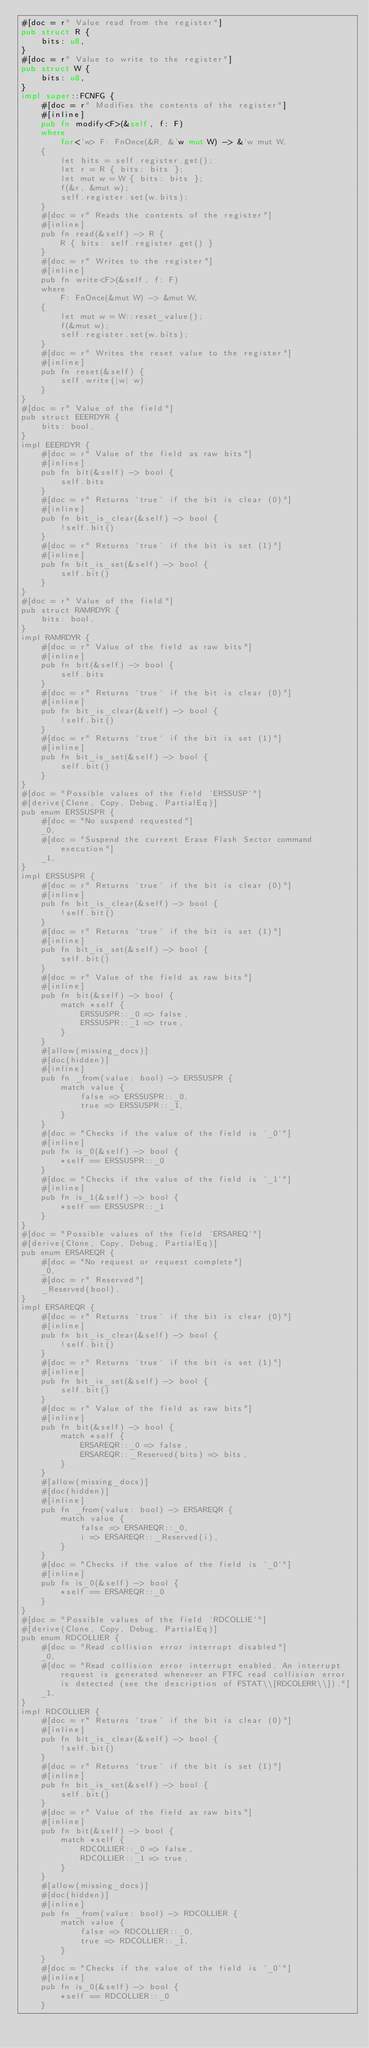<code> <loc_0><loc_0><loc_500><loc_500><_Rust_>#[doc = r" Value read from the register"]
pub struct R {
    bits: u8,
}
#[doc = r" Value to write to the register"]
pub struct W {
    bits: u8,
}
impl super::FCNFG {
    #[doc = r" Modifies the contents of the register"]
    #[inline]
    pub fn modify<F>(&self, f: F)
    where
        for<'w> F: FnOnce(&R, &'w mut W) -> &'w mut W,
    {
        let bits = self.register.get();
        let r = R { bits: bits };
        let mut w = W { bits: bits };
        f(&r, &mut w);
        self.register.set(w.bits);
    }
    #[doc = r" Reads the contents of the register"]
    #[inline]
    pub fn read(&self) -> R {
        R { bits: self.register.get() }
    }
    #[doc = r" Writes to the register"]
    #[inline]
    pub fn write<F>(&self, f: F)
    where
        F: FnOnce(&mut W) -> &mut W,
    {
        let mut w = W::reset_value();
        f(&mut w);
        self.register.set(w.bits);
    }
    #[doc = r" Writes the reset value to the register"]
    #[inline]
    pub fn reset(&self) {
        self.write(|w| w)
    }
}
#[doc = r" Value of the field"]
pub struct EEERDYR {
    bits: bool,
}
impl EEERDYR {
    #[doc = r" Value of the field as raw bits"]
    #[inline]
    pub fn bit(&self) -> bool {
        self.bits
    }
    #[doc = r" Returns `true` if the bit is clear (0)"]
    #[inline]
    pub fn bit_is_clear(&self) -> bool {
        !self.bit()
    }
    #[doc = r" Returns `true` if the bit is set (1)"]
    #[inline]
    pub fn bit_is_set(&self) -> bool {
        self.bit()
    }
}
#[doc = r" Value of the field"]
pub struct RAMRDYR {
    bits: bool,
}
impl RAMRDYR {
    #[doc = r" Value of the field as raw bits"]
    #[inline]
    pub fn bit(&self) -> bool {
        self.bits
    }
    #[doc = r" Returns `true` if the bit is clear (0)"]
    #[inline]
    pub fn bit_is_clear(&self) -> bool {
        !self.bit()
    }
    #[doc = r" Returns `true` if the bit is set (1)"]
    #[inline]
    pub fn bit_is_set(&self) -> bool {
        self.bit()
    }
}
#[doc = "Possible values of the field `ERSSUSP`"]
#[derive(Clone, Copy, Debug, PartialEq)]
pub enum ERSSUSPR {
    #[doc = "No suspend requested"]
    _0,
    #[doc = "Suspend the current Erase Flash Sector command execution"]
    _1,
}
impl ERSSUSPR {
    #[doc = r" Returns `true` if the bit is clear (0)"]
    #[inline]
    pub fn bit_is_clear(&self) -> bool {
        !self.bit()
    }
    #[doc = r" Returns `true` if the bit is set (1)"]
    #[inline]
    pub fn bit_is_set(&self) -> bool {
        self.bit()
    }
    #[doc = r" Value of the field as raw bits"]
    #[inline]
    pub fn bit(&self) -> bool {
        match *self {
            ERSSUSPR::_0 => false,
            ERSSUSPR::_1 => true,
        }
    }
    #[allow(missing_docs)]
    #[doc(hidden)]
    #[inline]
    pub fn _from(value: bool) -> ERSSUSPR {
        match value {
            false => ERSSUSPR::_0,
            true => ERSSUSPR::_1,
        }
    }
    #[doc = "Checks if the value of the field is `_0`"]
    #[inline]
    pub fn is_0(&self) -> bool {
        *self == ERSSUSPR::_0
    }
    #[doc = "Checks if the value of the field is `_1`"]
    #[inline]
    pub fn is_1(&self) -> bool {
        *self == ERSSUSPR::_1
    }
}
#[doc = "Possible values of the field `ERSAREQ`"]
#[derive(Clone, Copy, Debug, PartialEq)]
pub enum ERSAREQR {
    #[doc = "No request or request complete"]
    _0,
    #[doc = r" Reserved"]
    _Reserved(bool),
}
impl ERSAREQR {
    #[doc = r" Returns `true` if the bit is clear (0)"]
    #[inline]
    pub fn bit_is_clear(&self) -> bool {
        !self.bit()
    }
    #[doc = r" Returns `true` if the bit is set (1)"]
    #[inline]
    pub fn bit_is_set(&self) -> bool {
        self.bit()
    }
    #[doc = r" Value of the field as raw bits"]
    #[inline]
    pub fn bit(&self) -> bool {
        match *self {
            ERSAREQR::_0 => false,
            ERSAREQR::_Reserved(bits) => bits,
        }
    }
    #[allow(missing_docs)]
    #[doc(hidden)]
    #[inline]
    pub fn _from(value: bool) -> ERSAREQR {
        match value {
            false => ERSAREQR::_0,
            i => ERSAREQR::_Reserved(i),
        }
    }
    #[doc = "Checks if the value of the field is `_0`"]
    #[inline]
    pub fn is_0(&self) -> bool {
        *self == ERSAREQR::_0
    }
}
#[doc = "Possible values of the field `RDCOLLIE`"]
#[derive(Clone, Copy, Debug, PartialEq)]
pub enum RDCOLLIER {
    #[doc = "Read collision error interrupt disabled"]
    _0,
    #[doc = "Read collision error interrupt enabled. An interrupt request is generated whenever an FTFC read collision error is detected (see the description of FSTAT\\[RDCOLERR\\])."]
    _1,
}
impl RDCOLLIER {
    #[doc = r" Returns `true` if the bit is clear (0)"]
    #[inline]
    pub fn bit_is_clear(&self) -> bool {
        !self.bit()
    }
    #[doc = r" Returns `true` if the bit is set (1)"]
    #[inline]
    pub fn bit_is_set(&self) -> bool {
        self.bit()
    }
    #[doc = r" Value of the field as raw bits"]
    #[inline]
    pub fn bit(&self) -> bool {
        match *self {
            RDCOLLIER::_0 => false,
            RDCOLLIER::_1 => true,
        }
    }
    #[allow(missing_docs)]
    #[doc(hidden)]
    #[inline]
    pub fn _from(value: bool) -> RDCOLLIER {
        match value {
            false => RDCOLLIER::_0,
            true => RDCOLLIER::_1,
        }
    }
    #[doc = "Checks if the value of the field is `_0`"]
    #[inline]
    pub fn is_0(&self) -> bool {
        *self == RDCOLLIER::_0
    }</code> 